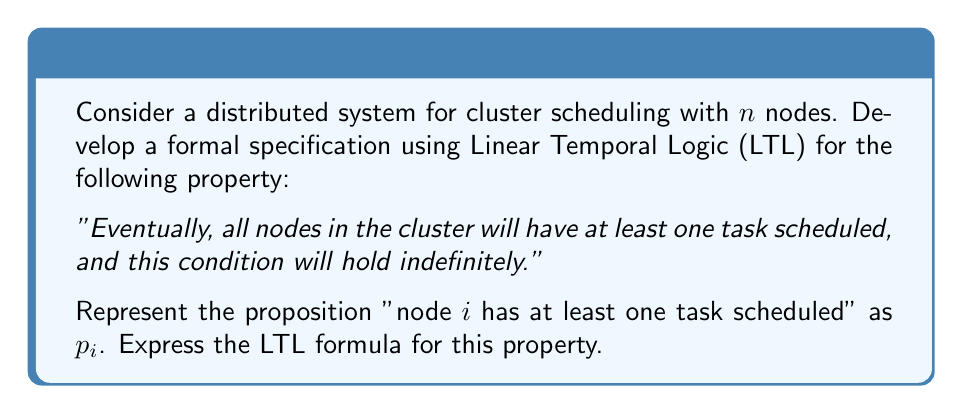Teach me how to tackle this problem. To develop the formal specification using Linear Temporal Logic (LTL), we'll follow these steps:

1. Define the basic proposition:
   $p_i$: "node $i$ has at least one task scheduled"

2. We need to express that this condition holds for all nodes. In LTL, we can use the conjunction of all $p_i$:
   $\bigwedge_{i=1}^n p_i$

3. The property states that this condition should eventually hold and then remain true indefinitely. In LTL, we can express this using the "Finally" (F) and "Globally" (G) operators:
   
   - "Finally" (F): The property will eventually hold
   - "Globally" (G): The property will always hold from that point onward

4. Combining these operators, we get:
   $F(G(\bigwedge_{i=1}^n p_i))$

This LTL formula reads as: "Eventually (F), it will always be the case (G) that all nodes have at least one task scheduled (conjunction of all $p_i$)."

This formal specification captures the required property for the distributed system, ensuring that all nodes in the cluster will eventually have tasks scheduled and maintain this state indefinitely.
Answer: $$F(G(\bigwedge_{i=1}^n p_i))$$ 